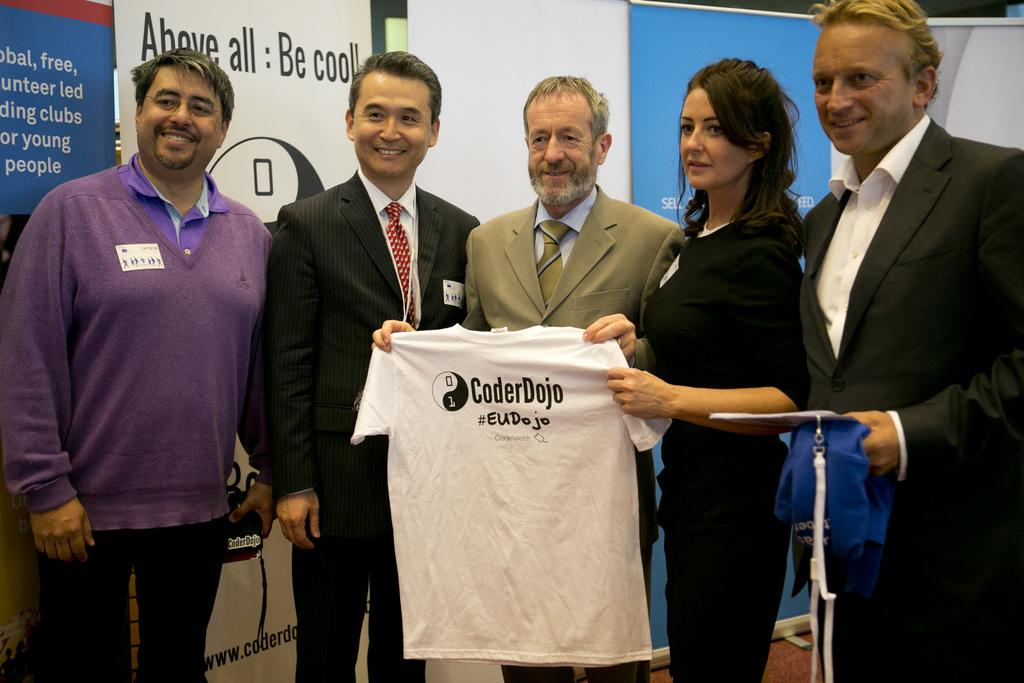How many people are in the image? There are many persons standing on the floor in the image. What are the persons holding in their hands? The persons are holding cameras and t-shirts. What can be seen in the background of the image? There are advertisements and a wall visible in the background of the image. What type of hair is the queen wearing in the image? There is no queen or hair present in the image; it features a group of persons holding cameras and t-shirts. How does the self-awareness of the persons in the image affect their actions? The provided facts do not mention self-awareness or any actions related to it, so we cannot determine its effect on the persons in the image. 